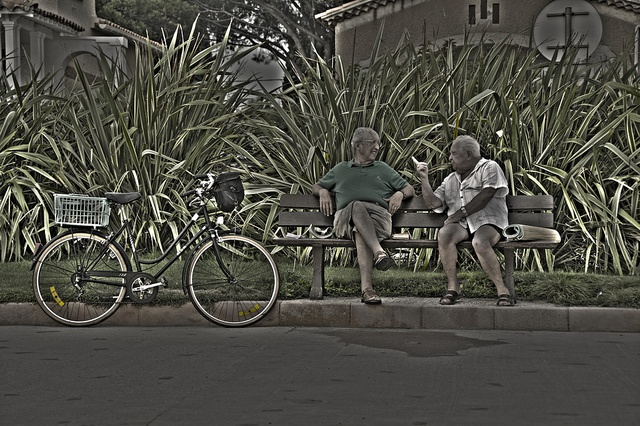Describe the objects in this image and their specific colors. I can see bicycle in black, gray, and darkgray tones, people in black, gray, darkgray, and lightgray tones, people in black, gray, and darkgray tones, and bench in black, gray, and darkgray tones in this image. 